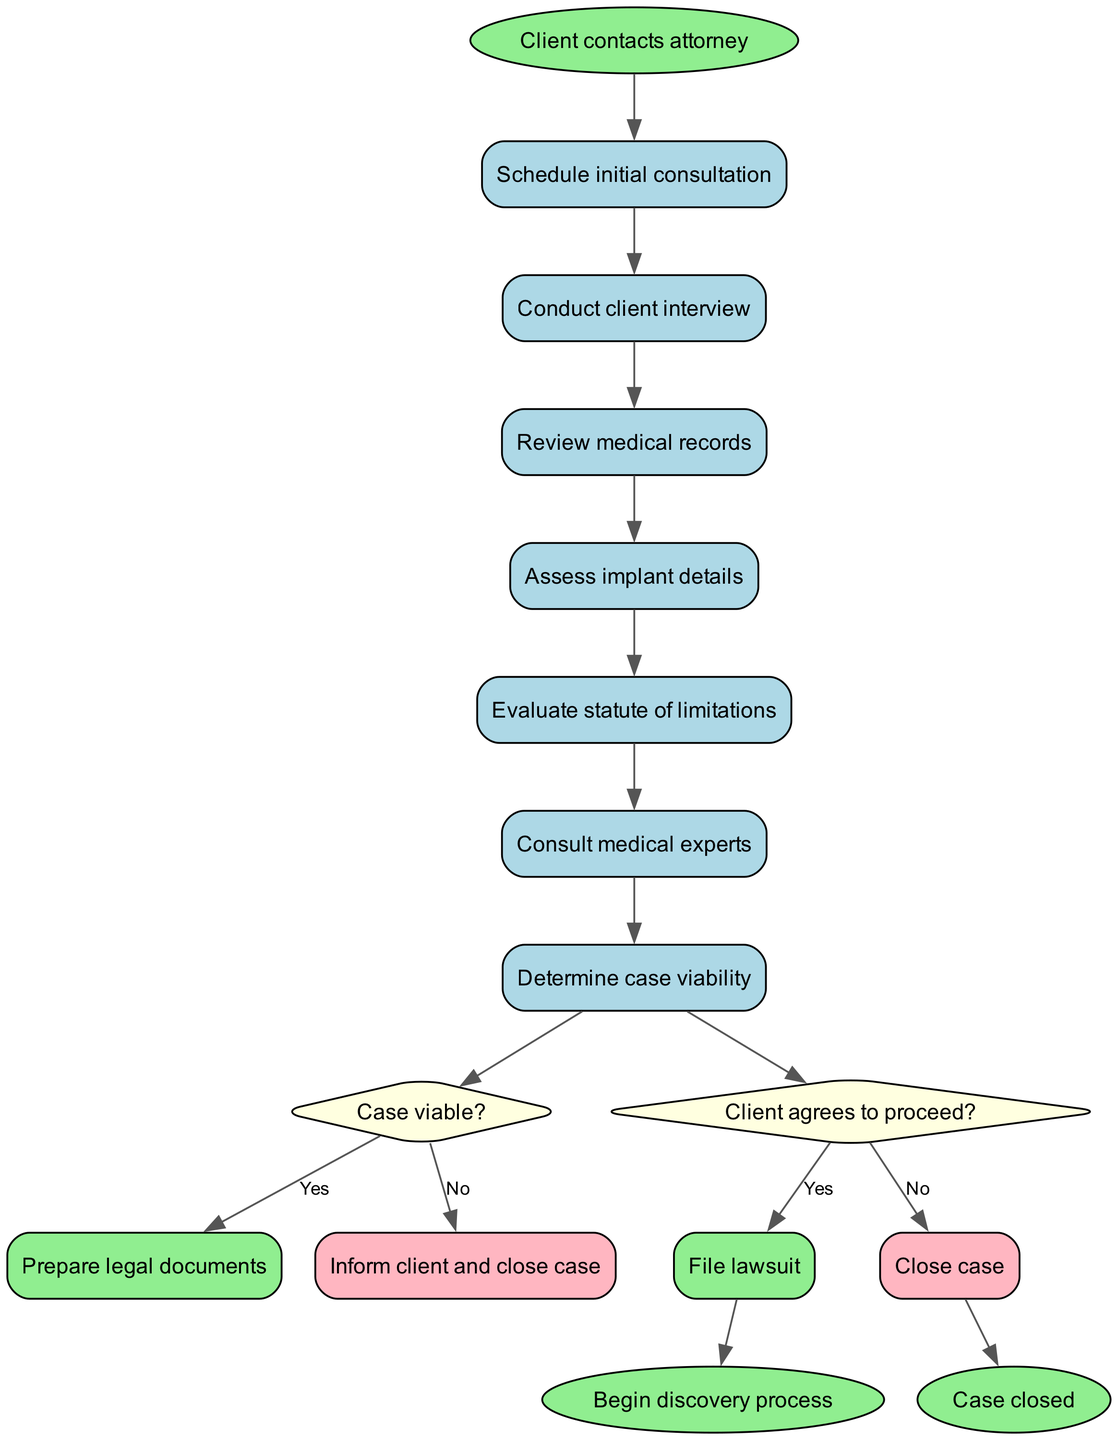What is the initial node in the process? The initial node, shown in the diagram as the starting point, is "Client contacts attorney." This is the first step in the patient intake process.
Answer: Client contacts attorney How many activities are included in the diagram? There are 7 activities listed in the diagram, which are the steps the attorney will take after the initial contact.
Answer: 7 What happens if the case is not viable? If the decision from the "Case viable?" diamond is "No," the process leads to the action "Inform client and close case," indicating the conclusion of the case due to viability issues.
Answer: Inform client and close case After assessing the implant details, what decision is made? Following the activity "Assess implant details," the process moves to the decision node "Case viable?" which determines the future steps based on the viability of the case.
Answer: Case viable? What final nodes are present in the diagram? There are two final nodes: "Begin discovery process" and "Case closed," which indicate the outcomes after determining the path of the case based on client agreement and case viability.
Answer: Begin discovery process, Case closed If the client does not agree to proceed, what will happen next? If the client decides not to proceed after the decision "Client agrees to proceed?", the flow leads directly to "Close case," indicating the termination of the legal process at that point.
Answer: Close case What is the last activity before the decision on case viability? The last activity before the decision "Case viable?" is "Assess implant details," which is pivotal in determining if there is a valid case to pursue regarding the medical implant.
Answer: Assess implant details What is the outcome if the client agrees to file a lawsuit? If the decision is "Yes" to "Client agrees to proceed?", the next action is to "File lawsuit," signifying the attorney's formal initiation of legal proceedings on behalf of the client.
Answer: File lawsuit 